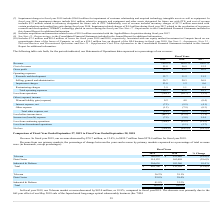According to Macom Technology's financial document, What led to I&D market revenues to increase in fiscal year 2019? Based on the financial document, the answer is higher revenue from sales across the product portfolio.. Also, can you calculate: What is the change in Telecom value between fiscal year 2018 and 2019? Based on the calculation: 180,938-222,940, the result is -42002 (in thousands). This is based on the information: "Telecom $ 180,938 $ 222,940 (18.8)% Telecom $ 180,938 $ 222,940 (18.8)%..." The key data points involved are: 180,938, 222,940. Also, can you calculate: What is the average Telecom for fiscal year 2018 and 2019? To answer this question, I need to perform calculations using the financial data. The calculation is: (180,938+222,940) / 2, which equals 201939 (in thousands). This is based on the information: "Telecom $ 180,938 $ 222,940 (18.8)% Telecom $ 180,938 $ 222,940 (18.8)%..." The key data points involved are: 180,938, 222,940. Additionally, In which year was Telecom less than 200,000 thousand? According to the financial document, 2019. The relevant text states: "2019 2018 % Change..." Also, What was the value of Data Center in 2019 and 2018 respectively? The document shows two values: 114,132 and 162,098 (in thousands). From the document: "Data Center 114,132 162,098 (29.6)% Data Center 114,132 162,098 (29.6)%..." Also, What was the decrease in the revenue in 2019? According to the financial document, $70.7 million. The relevant text states: "nue. In fiscal year 2019, our revenue decreased by $70.7 million, or 12.4%, to $499.7 million from $570.4 million for fiscal year 2018...." 